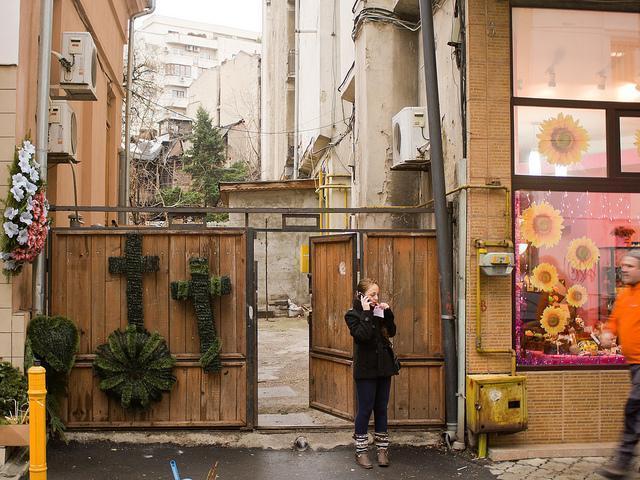What shape are two of the grass wreaths fashioned into?
Select the accurate answer and provide justification: `Answer: choice
Rationale: srationale.`
Options: Octagon, rectangle, tree, cross. Answer: cross.
Rationale: There are four grass wreaths in total but only one shape is shared by two of the wreaths and that shape is a cross. 